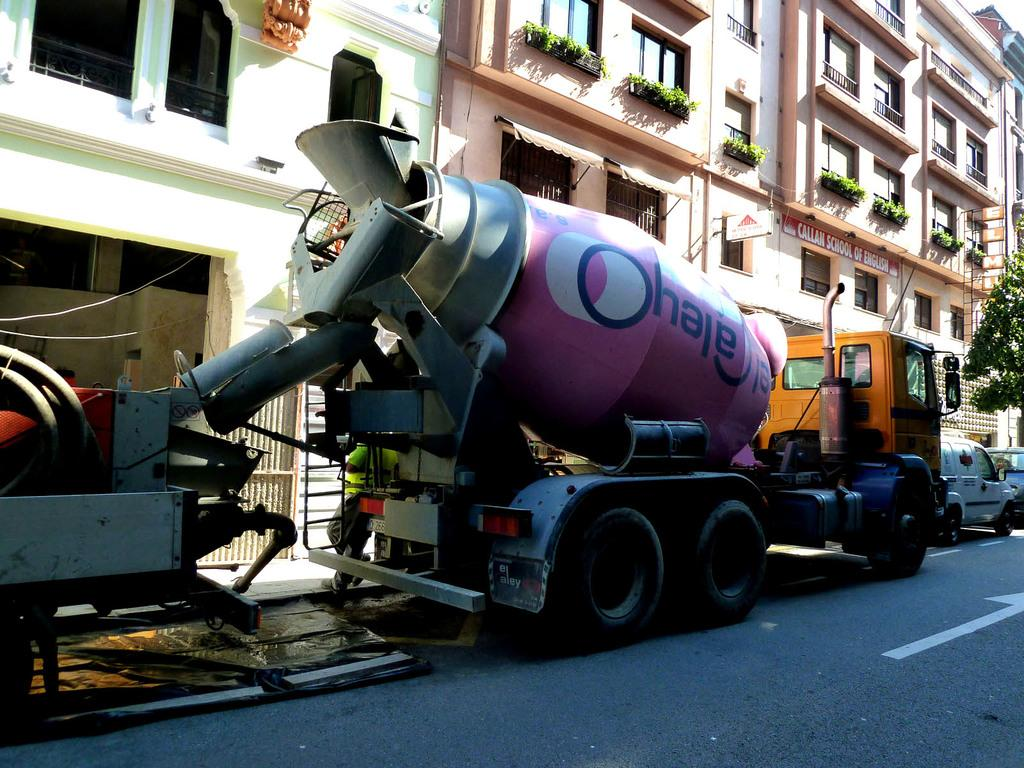What is the main subject of the image? The main subject of the image is a truck. Are there any other vehicles in the image? Yes, there are two other vehicles in front of the truck. What can be seen behind the vehicles? There is a huge building behind the vehicles. What type of vegetation is on the right side of the image? There is a tree on the right side of the image. What is the name of the owner of the truck in the image? There is no information about the truck's owner in the image. What type of power source does the truck use in the image? The image does not provide information about the truck's power source. 